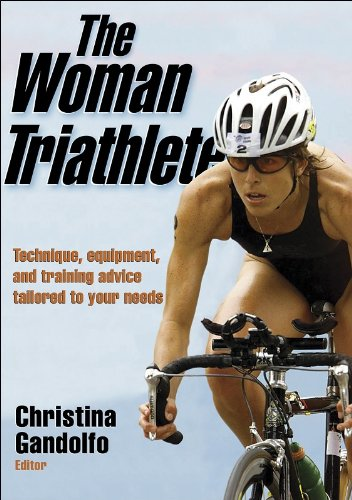Is this a youngster related book? No, this book is not specifically targeted at youngsters. It focuses on training and equipment for adult women who are either entering or are already involved in the sport of triathlon. 